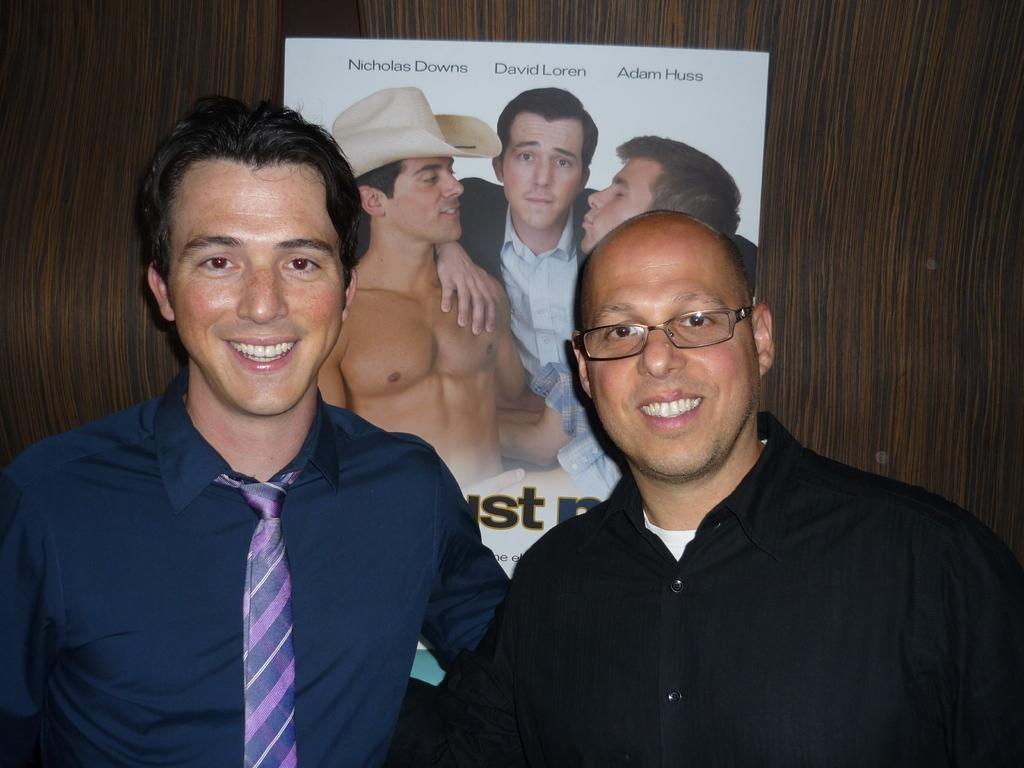How many persons are in the image? There are persons in the image. What is the facial expression of the persons in the image? The persons are smiling. What can be seen in the background of the image? There is a poster in the background of the image. What type of content is present on the poster? The poster contains text and images. What type of wren can be seen perched on the poster in the image? There is no wren present in the image, let alone perched on the poster. 